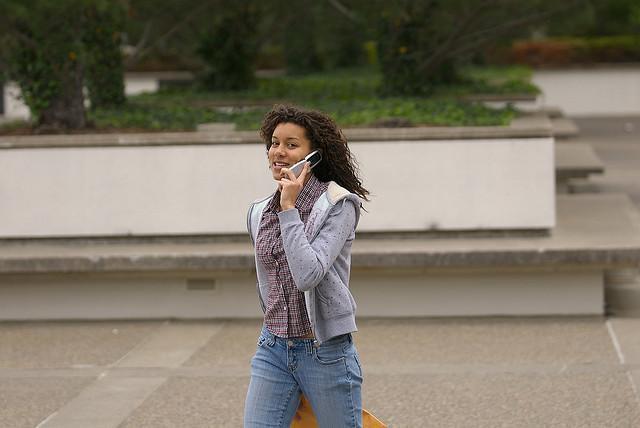How many people can you see?
Give a very brief answer. 1. 